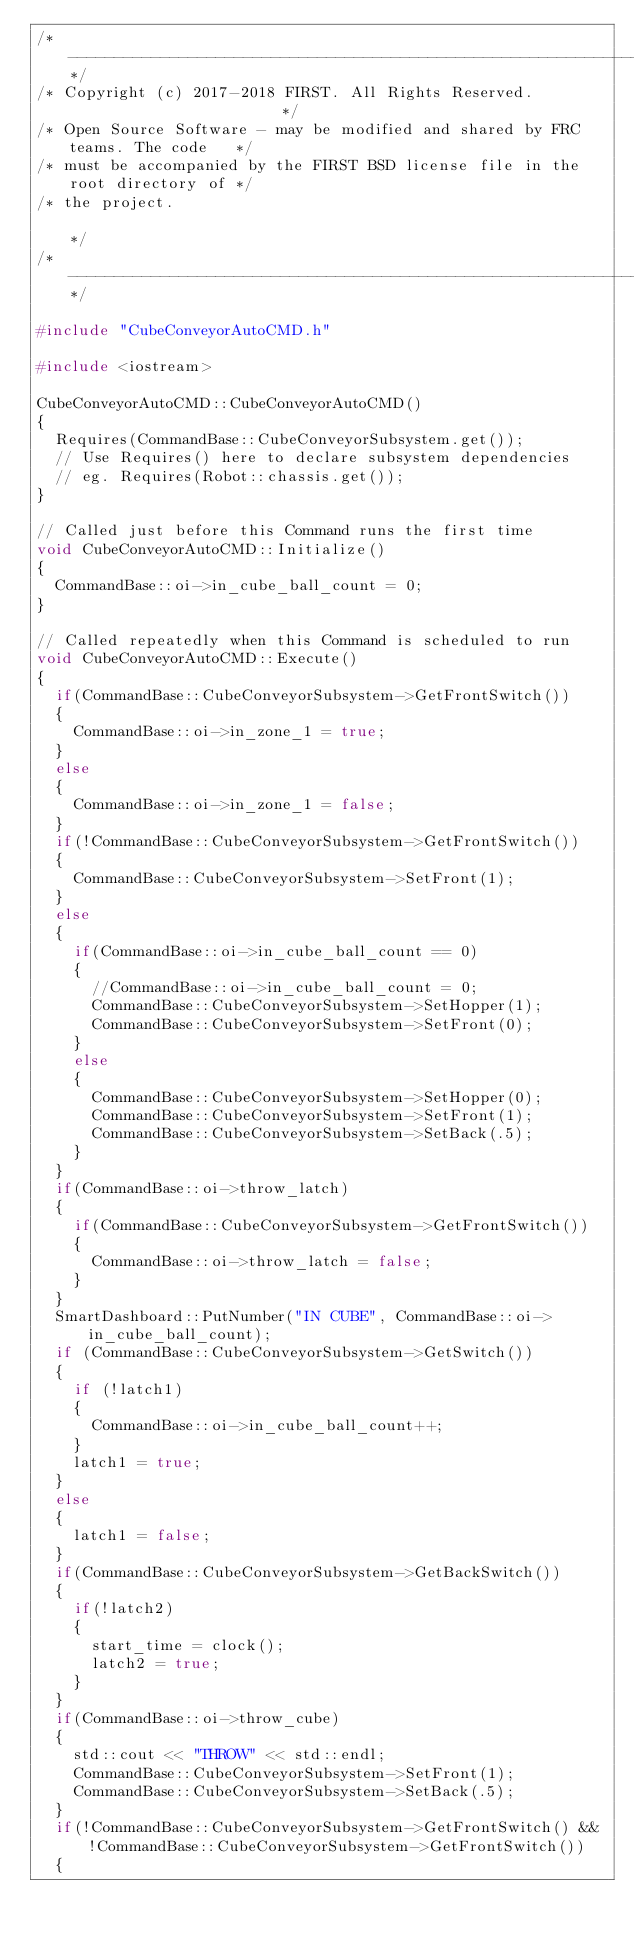<code> <loc_0><loc_0><loc_500><loc_500><_C++_>/*----------------------------------------------------------------------------*/
/* Copyright (c) 2017-2018 FIRST. All Rights Reserved.                        */
/* Open Source Software - may be modified and shared by FRC teams. The code   */
/* must be accompanied by the FIRST BSD license file in the root directory of */
/* the project.                                                               */
/*----------------------------------------------------------------------------*/

#include "CubeConveyorAutoCMD.h"

#include <iostream>

CubeConveyorAutoCMD::CubeConveyorAutoCMD()
{
	Requires(CommandBase::CubeConveyorSubsystem.get());
	// Use Requires() here to declare subsystem dependencies
	// eg. Requires(Robot::chassis.get());
}

// Called just before this Command runs the first time
void CubeConveyorAutoCMD::Initialize()
{
	CommandBase::oi->in_cube_ball_count = 0;
}

// Called repeatedly when this Command is scheduled to run
void CubeConveyorAutoCMD::Execute()
{
	if(CommandBase::CubeConveyorSubsystem->GetFrontSwitch())
	{
		CommandBase::oi->in_zone_1 = true;
	}
	else
	{
		CommandBase::oi->in_zone_1 = false;
	}
	if(!CommandBase::CubeConveyorSubsystem->GetFrontSwitch())
	{
		CommandBase::CubeConveyorSubsystem->SetFront(1);
	}
	else
	{
		if(CommandBase::oi->in_cube_ball_count == 0)
		{
			//CommandBase::oi->in_cube_ball_count = 0;
			CommandBase::CubeConveyorSubsystem->SetHopper(1);
			CommandBase::CubeConveyorSubsystem->SetFront(0);
		}
		else
		{
			CommandBase::CubeConveyorSubsystem->SetHopper(0);
			CommandBase::CubeConveyorSubsystem->SetFront(1);
			CommandBase::CubeConveyorSubsystem->SetBack(.5);
		}
	}
	if(CommandBase::oi->throw_latch)
	{
		if(CommandBase::CubeConveyorSubsystem->GetFrontSwitch())
		{
			CommandBase::oi->throw_latch = false;
		}
	}
	SmartDashboard::PutNumber("IN CUBE", CommandBase::oi->in_cube_ball_count);
	if (CommandBase::CubeConveyorSubsystem->GetSwitch())
	{
		if (!latch1)
		{
			CommandBase::oi->in_cube_ball_count++;
		}
		latch1 = true;
	}
	else
	{
		latch1 = false;
	}
	if(CommandBase::CubeConveyorSubsystem->GetBackSwitch())
	{
		if(!latch2)
		{
			start_time = clock();
			latch2 = true;
		}
	}
	if(CommandBase::oi->throw_cube)
	{
		std::cout << "THROW" << std::endl;
		CommandBase::CubeConveyorSubsystem->SetFront(1);
		CommandBase::CubeConveyorSubsystem->SetBack(.5);
	}
	if(!CommandBase::CubeConveyorSubsystem->GetFrontSwitch() && !CommandBase::CubeConveyorSubsystem->GetFrontSwitch())
	{</code> 